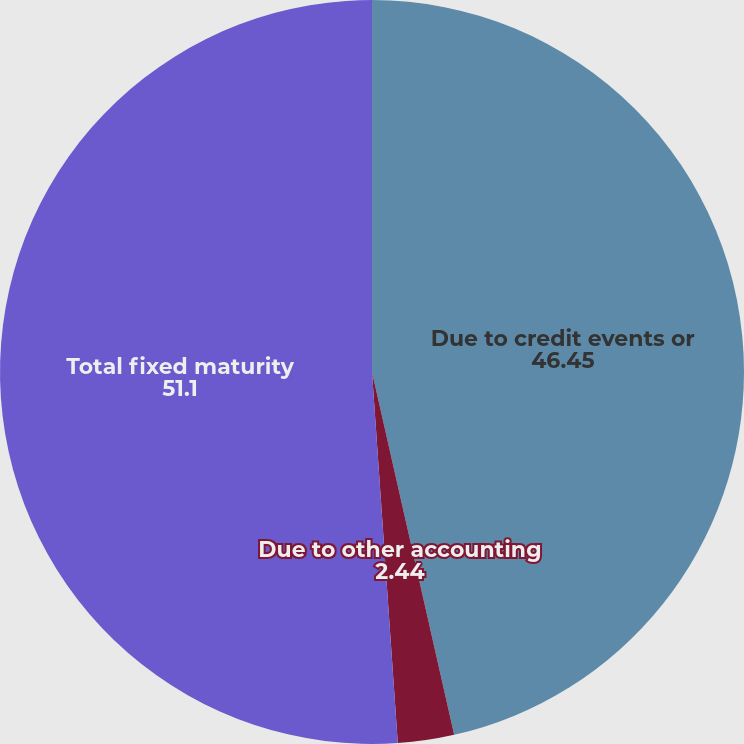Convert chart. <chart><loc_0><loc_0><loc_500><loc_500><pie_chart><fcel>Due to credit events or<fcel>Due to other accounting<fcel>Total fixed maturity<nl><fcel>46.45%<fcel>2.44%<fcel>51.1%<nl></chart> 